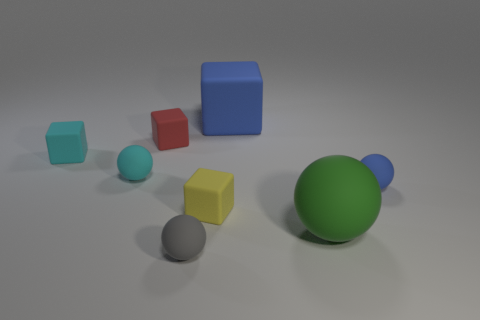What number of blue objects are either matte objects or small rubber spheres?
Your answer should be very brief. 2. Is the number of tiny cyan rubber cubes greater than the number of small red metal cylinders?
Offer a very short reply. Yes. Do the matte cube that is right of the small yellow matte cube and the rubber sphere that is to the left of the small gray thing have the same size?
Offer a terse response. No. What color is the big rubber object that is in front of the matte ball to the left of the tiny matte ball in front of the green matte ball?
Ensure brevity in your answer.  Green. Is there a small red matte thing that has the same shape as the yellow matte thing?
Your answer should be very brief. Yes. Is the number of small yellow objects that are behind the tiny blue sphere greater than the number of large green balls?
Your answer should be very brief. No. How many rubber objects are either tiny red things or small gray things?
Your response must be concise. 2. There is a object that is left of the red rubber cube and in front of the tiny cyan rubber cube; how big is it?
Your answer should be very brief. Small. There is a tiny rubber sphere in front of the yellow rubber cube; is there a gray object in front of it?
Ensure brevity in your answer.  No. There is a yellow rubber object; how many small balls are behind it?
Give a very brief answer. 2. 